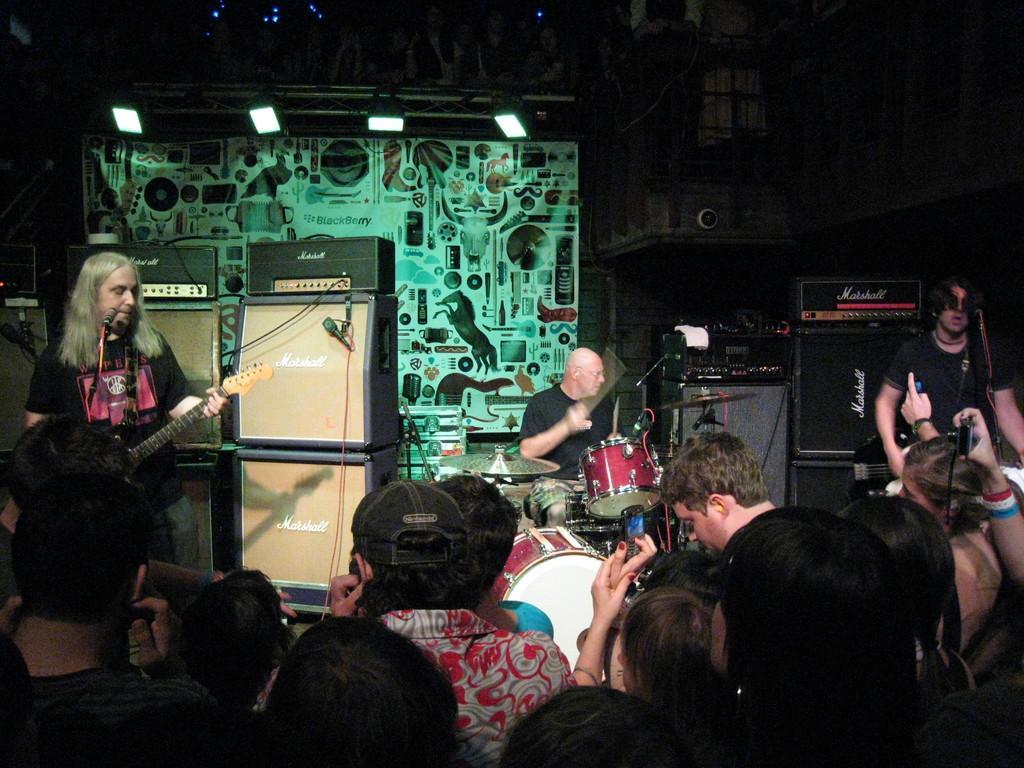How would you summarize this image in a sentence or two? These two persons are standing and playing guitar,this person sitting and playing drum. On the background we can see banner,focusing lights and musical instruments. These are audience and this person holding mobile and this person holding camera. There are microphones with stands. 